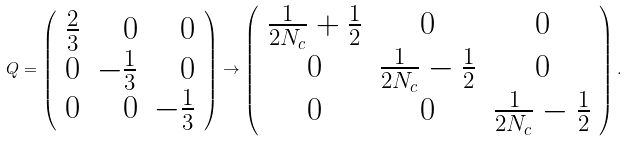Convert formula to latex. <formula><loc_0><loc_0><loc_500><loc_500>Q = \left ( \begin{array} { r r r } \frac { 2 } { 3 } & 0 & 0 \\ 0 & - \frac { 1 } { 3 } & 0 \\ 0 & 0 & - \frac { 1 } { 3 } \end{array} \right ) \to \left ( \begin{array} { c c c } \frac { 1 } { 2 N _ { c } } + \frac { 1 } { 2 } & 0 & 0 \\ 0 & \frac { 1 } { 2 N _ { c } } - \frac { 1 } { 2 } & 0 \\ 0 & 0 & \frac { 1 } { 2 N _ { c } } - \frac { 1 } { 2 } \end{array} \right ) .</formula> 